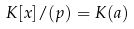Convert formula to latex. <formula><loc_0><loc_0><loc_500><loc_500>K [ x ] / ( p ) = K ( a )</formula> 